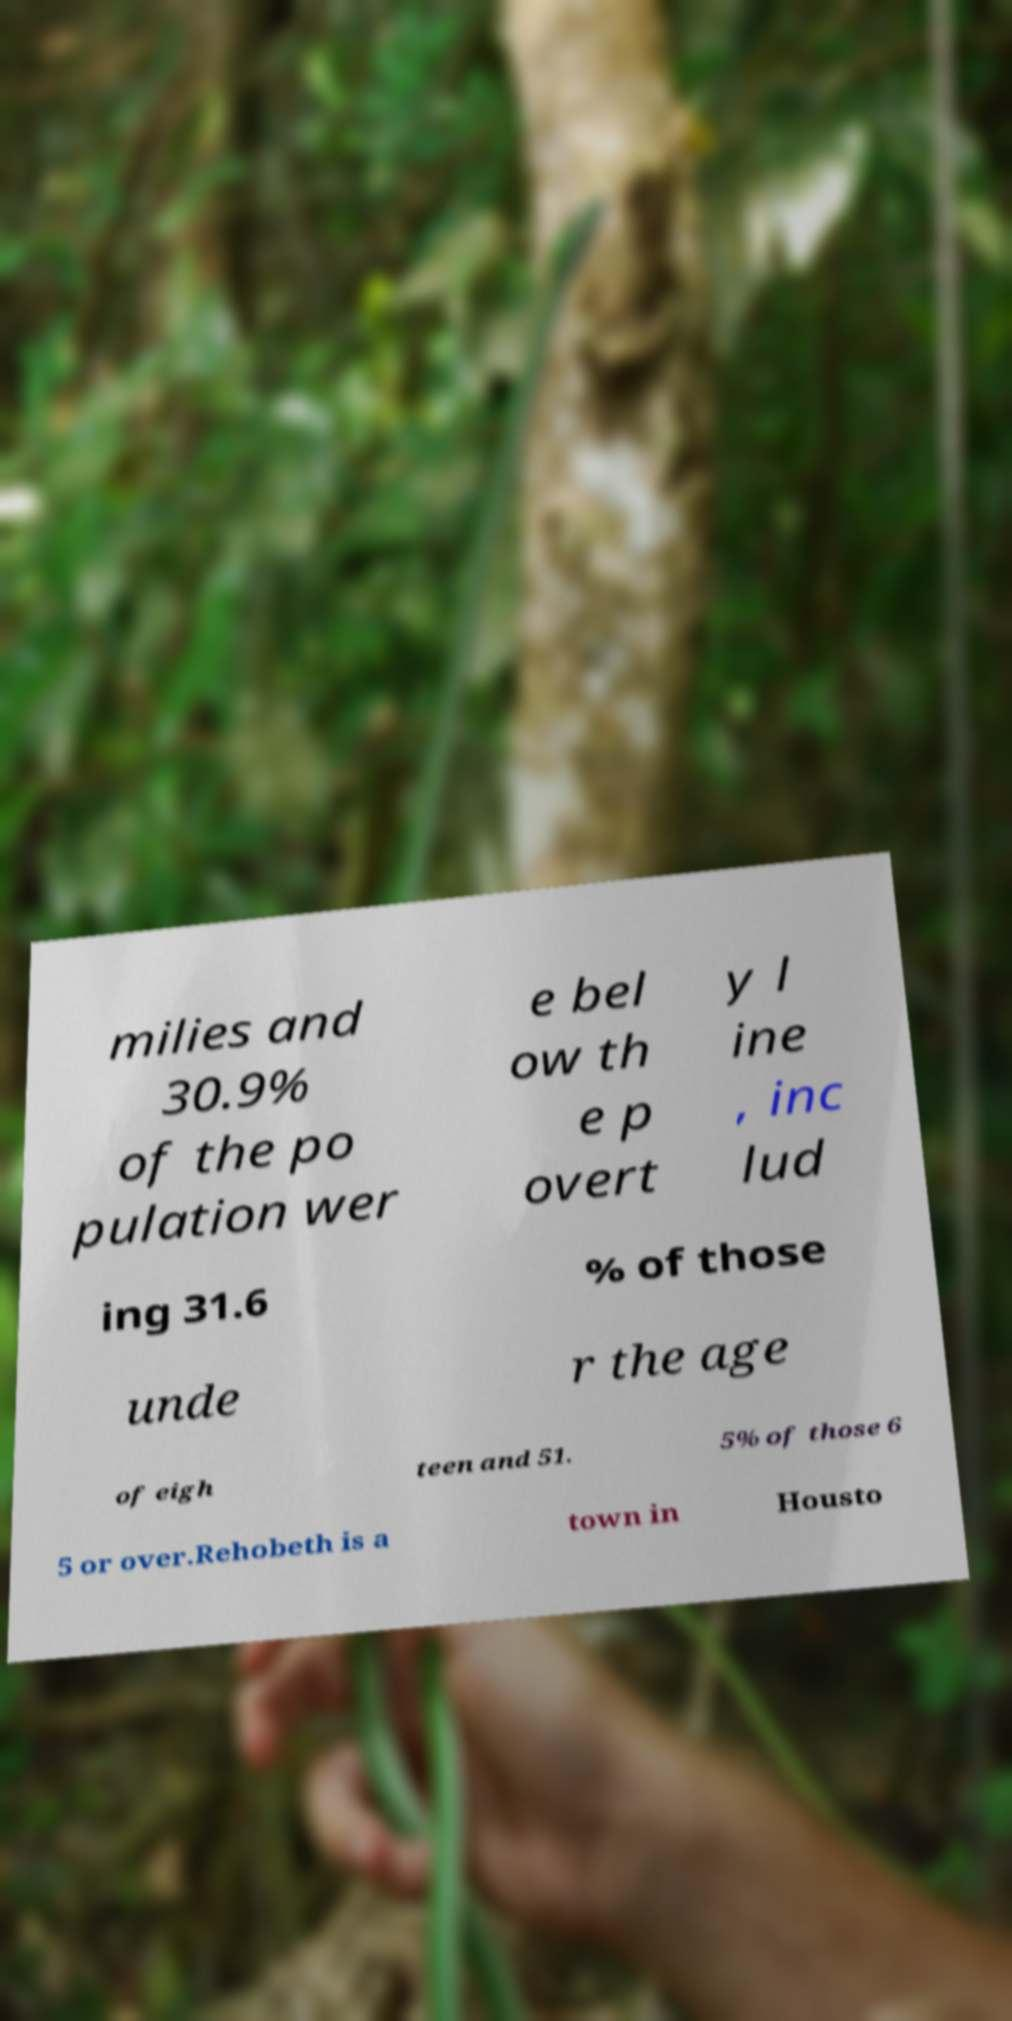Please read and relay the text visible in this image. What does it say? milies and 30.9% of the po pulation wer e bel ow th e p overt y l ine , inc lud ing 31.6 % of those unde r the age of eigh teen and 51. 5% of those 6 5 or over.Rehobeth is a town in Housto 